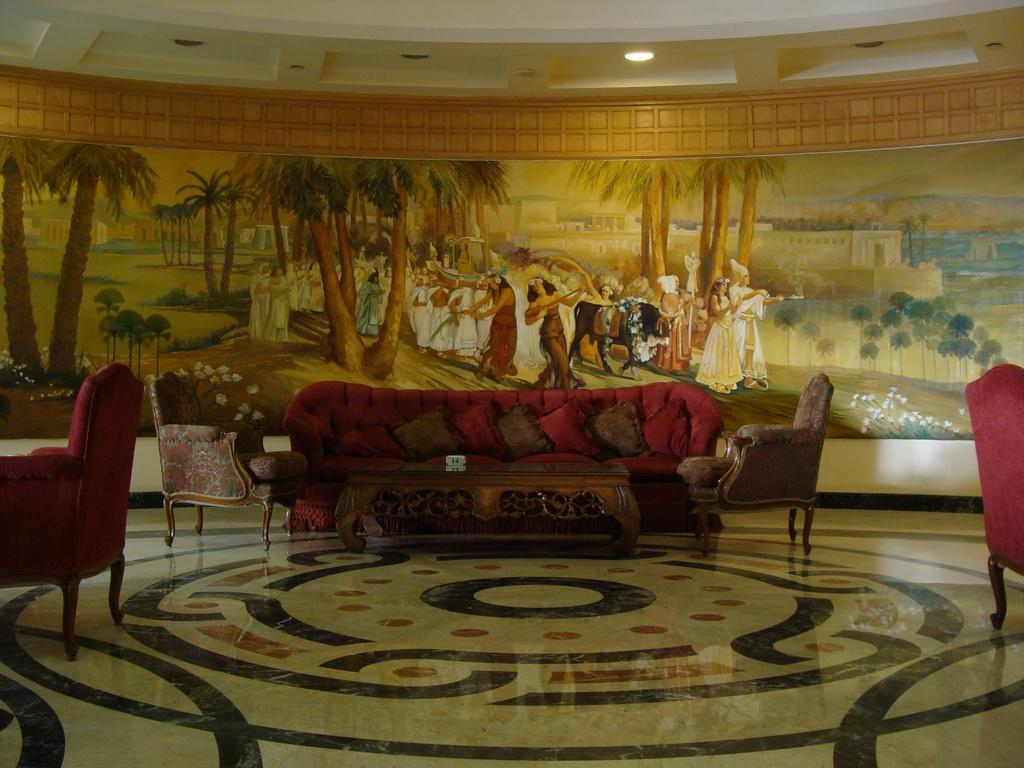What type of furniture is in the image? There is a sofa in the image. What is visible beneath the sofa? The image shows a floor. What can be seen in the background of the image? There is a wall in the background of the image. What is hanging on the wall? There is a painting on the wall. What provides illumination in the image? There is a light in the image. What type of horn can be seen on the ground in the image? There is no horn present on the ground in the image. 